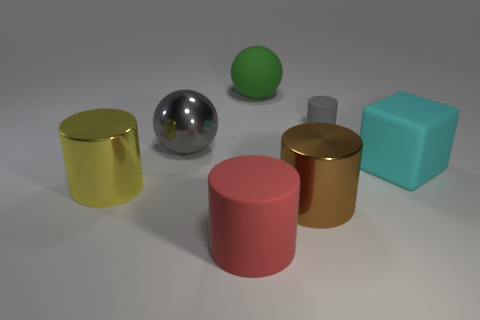Is there anything else that is the same size as the gray rubber object?
Your answer should be very brief. No. Is there anything else that has the same shape as the large cyan thing?
Ensure brevity in your answer.  No. What is the shape of the other thing that is the same color as the tiny matte thing?
Ensure brevity in your answer.  Sphere. What material is the large gray object that is the same shape as the green matte object?
Provide a succinct answer. Metal. How many other objects are the same size as the gray ball?
Your response must be concise. 5. What is the material of the big green ball?
Give a very brief answer. Rubber. Is the number of green matte balls in front of the small rubber object greater than the number of big cylinders?
Give a very brief answer. No. Is there a tiny gray block?
Your answer should be compact. No. What number of other objects are the same shape as the small thing?
Your answer should be very brief. 3. Does the large sphere that is right of the red matte thing have the same color as the large shiny cylinder behind the brown thing?
Provide a short and direct response. No. 